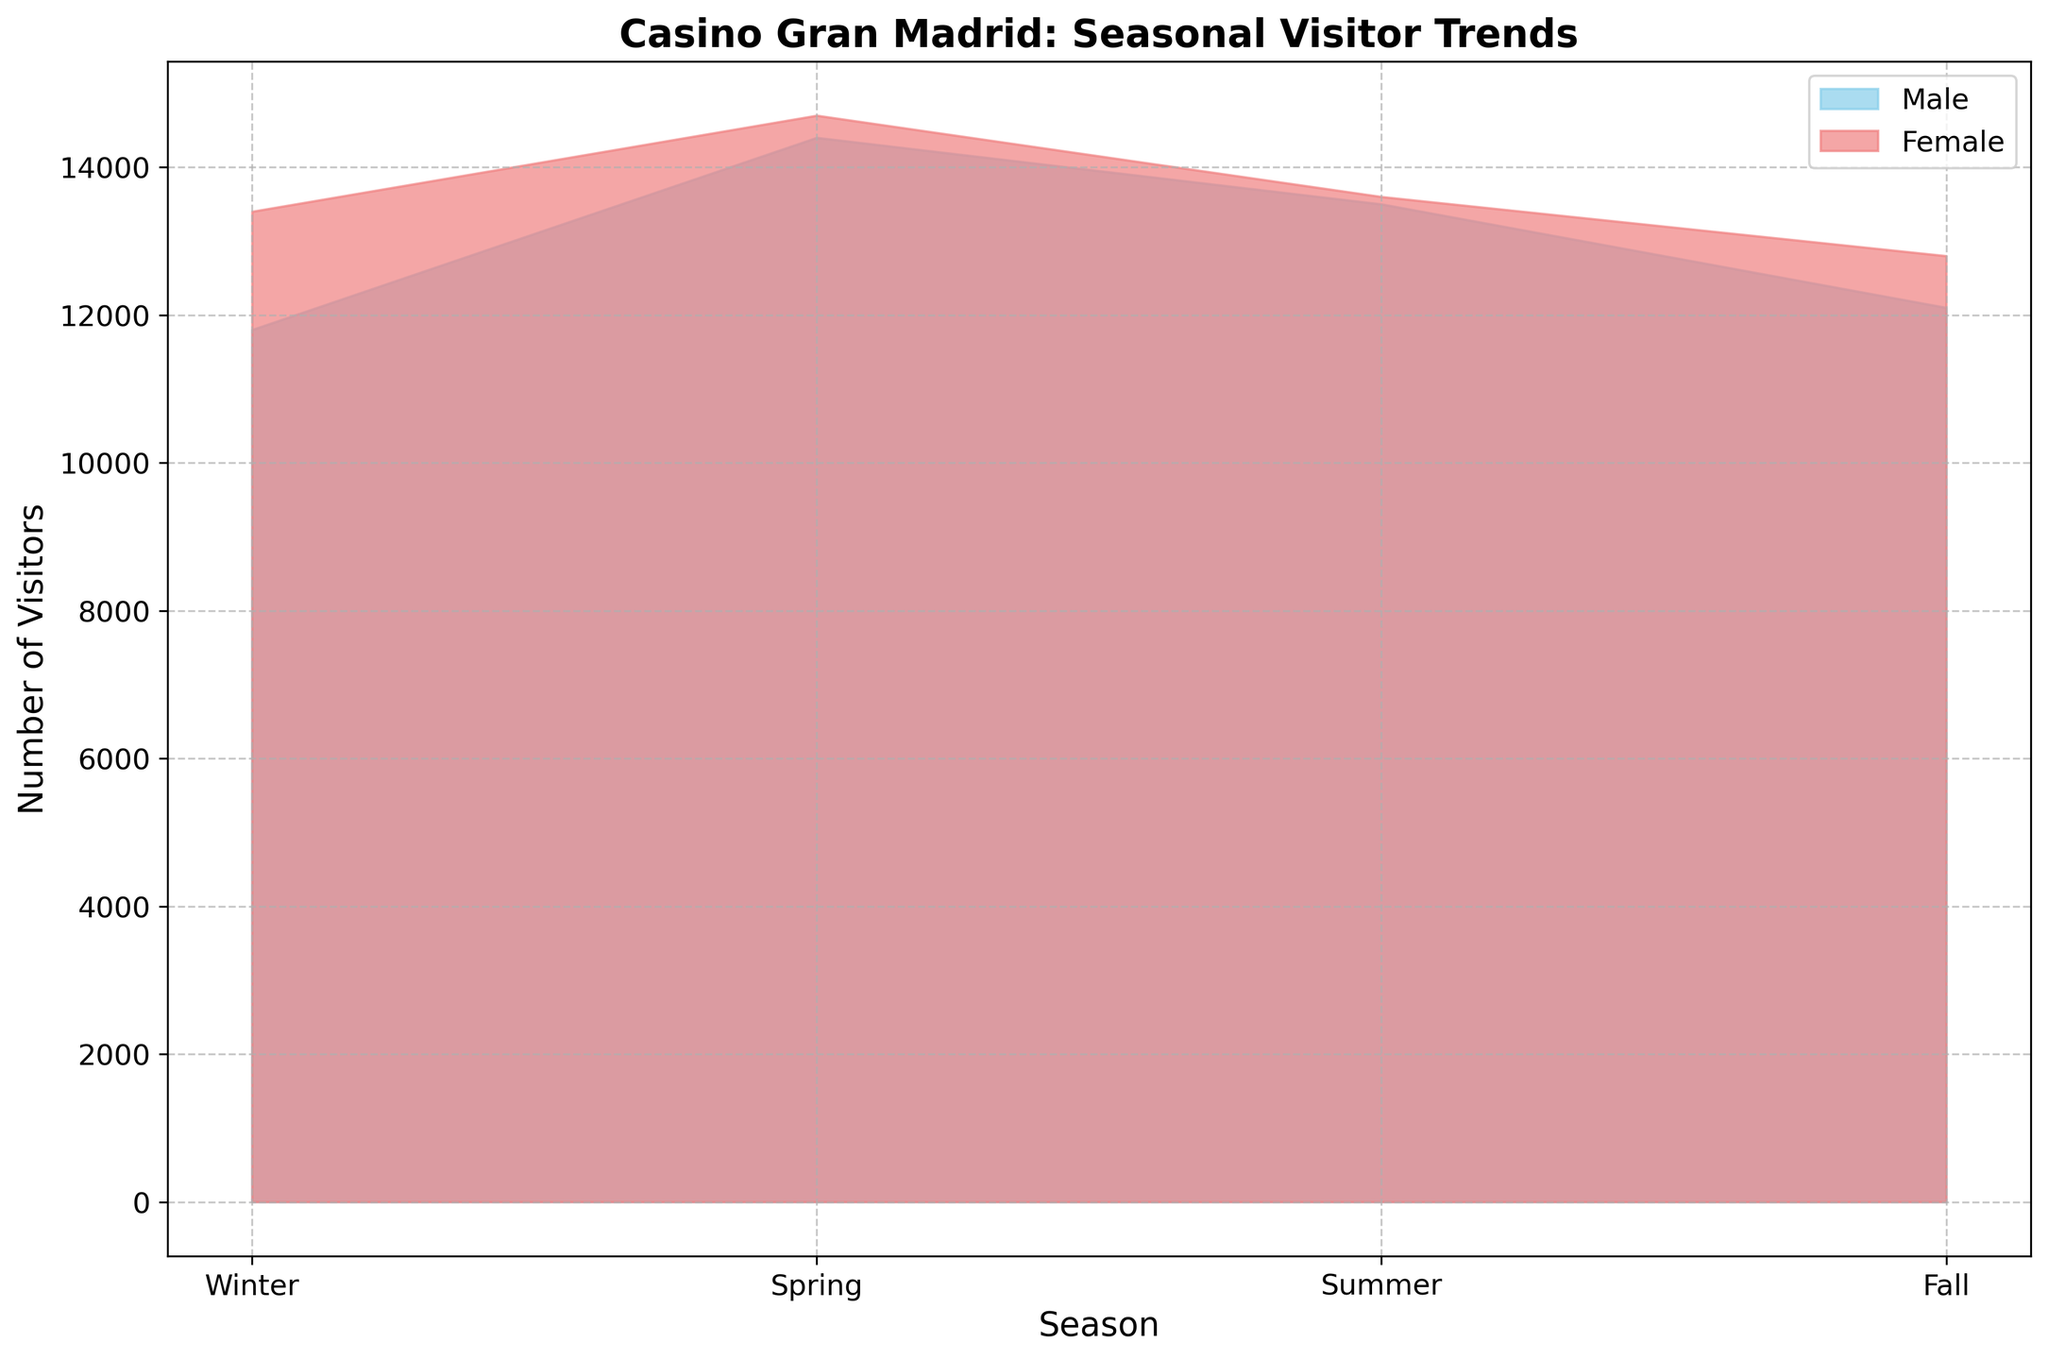Which season had the highest number of male visitors? To identify the season with the highest number of male visitors, look at the height of the skyblue areas across different seasons. The highest skyblue area indicates the season with the most male visitors.
Answer: Spring Which season had the highest number of female visitors? To pinpoint the season with the highest number of female visitors, examine the height of the lightcoral areas for each season. The season with the highest lightcoral area corresponds to the highest number of female visitors.
Answer: Spring Which age group saw the greatest increase in visitors from Winter to Spring? To find the age group with the greatest increase, we need to compare the number of visitors of each age group from Winter to Spring and look for the largest difference.
Answer: 26-35 Female In which season is the difference between male and female visitors the smallest? To determine when the difference between male and female visitors is smallest, compare the gap between the skyblue and lightcoral areas for each season. The season with the smallest gap has the smallest difference.
Answer: Summer What is the total number of visitors in Winter? Sum up the visitors from all demographic groups for Winter. That is: 3000 + 3200 + 2800 + 3500 + 2500 + 2700 + 2000 + 2300 + 1500 + 1700.
Answer: 25200 What is the overall trend for the 18-25 age group throughout the year? By visually inspecting the sections of the skyblue and lightcoral areas corresponding to the 18-25 age group across all seasons, observe whether the area increases or decreases.
Answer: Mostly stable with a peak in Spring Compare the total number of visitors in Spring and Fall. Which season had more visitors? Sum up the number of visitors for all demographic groups in each season, then compare the totals. For Spring: 3500 + 3400 + 3700 + 3800 + 2900 + 3000 + 2500 + 2600 + 1800 + 1900. For Fall: 2800 + 3000 + 3100 + 3200 + 2500 + 2600 + 2100 + 2200 + 1600 + 1800. Compare the totals.
Answer: Spring had more visitors In which season do male and female visitor numbers align most closely? Examine the skyblue and lightcoral areas across all seasons, focusing where the two areas are closest in height, indicating similar visitor numbers.
Answer: Summer Which demographic group showed the least variation in visitor numbers across the seasons? Look for the demographic group where the height of corresponding areas (both skyblue and lightcoral) remains relatively constant across all seasons.
Answer: 56+ Male 